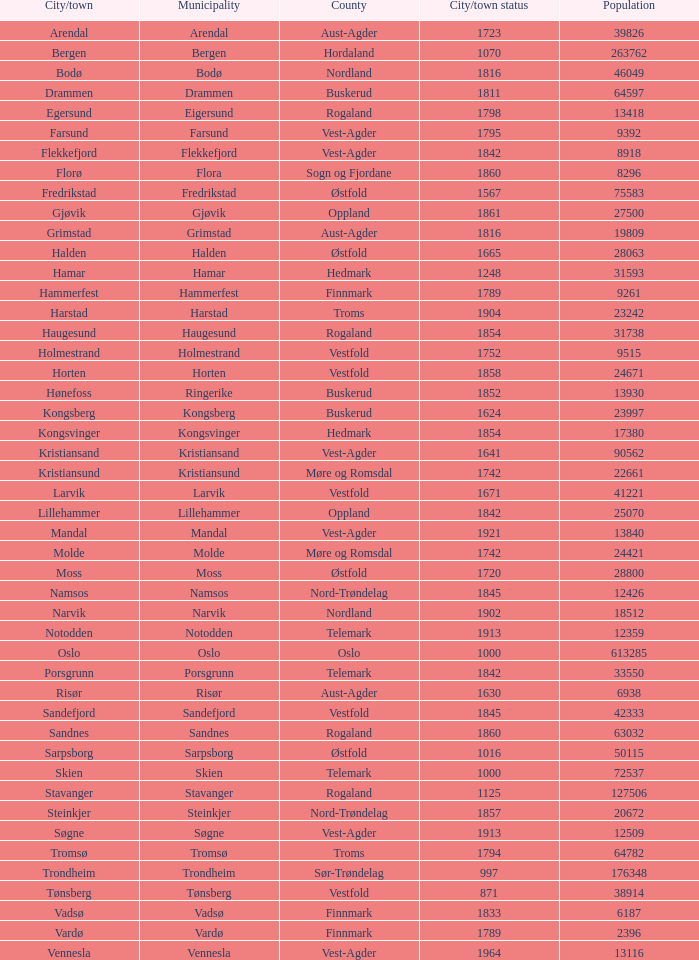What are the urban areas situated in the municipality of moss? Moss. 